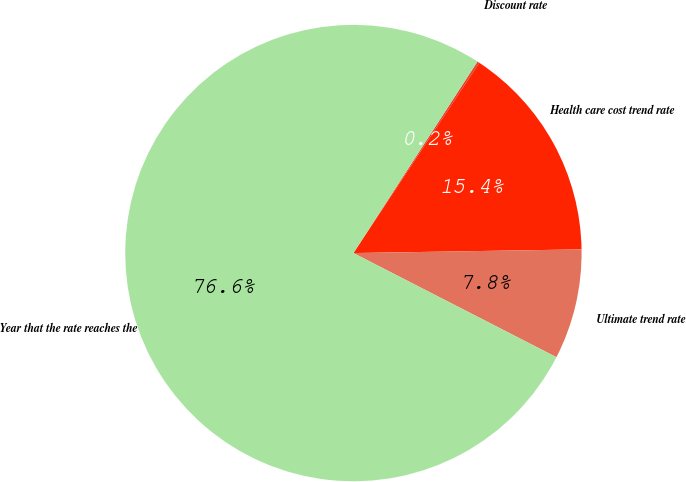<chart> <loc_0><loc_0><loc_500><loc_500><pie_chart><fcel>Discount rate<fcel>Health care cost trend rate<fcel>Ultimate trend rate<fcel>Year that the rate reaches the<nl><fcel>0.15%<fcel>15.44%<fcel>7.8%<fcel>76.61%<nl></chart> 